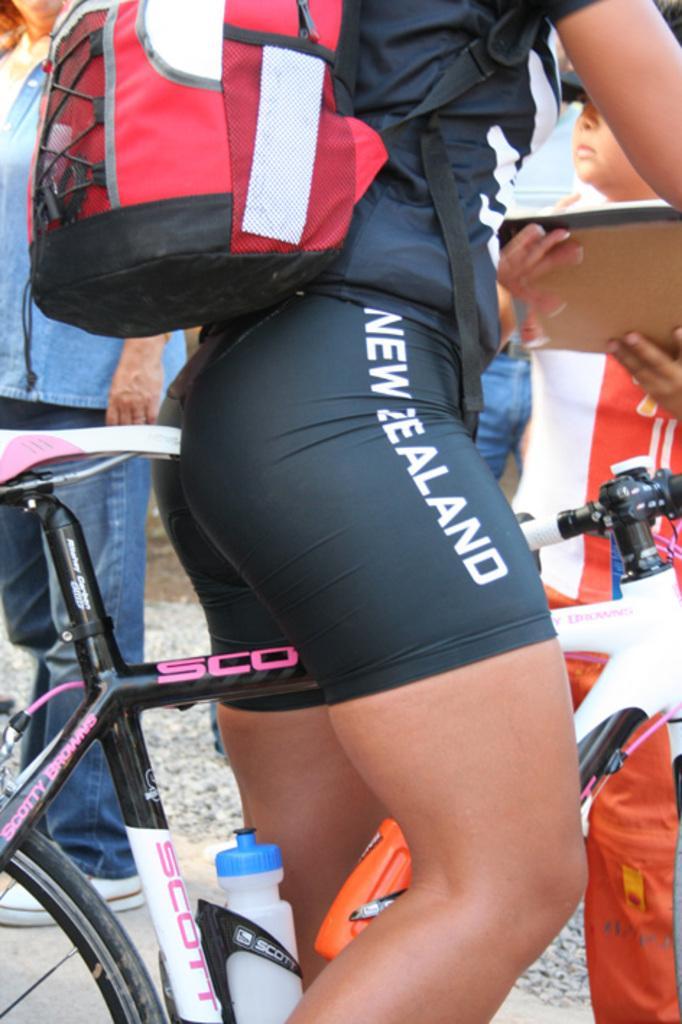Could you give a brief overview of what you see in this image? This is the picture of a person who is sitting on the bicycle wearing black and white shirt and shorts and a backpack in red ,black and white in color. 